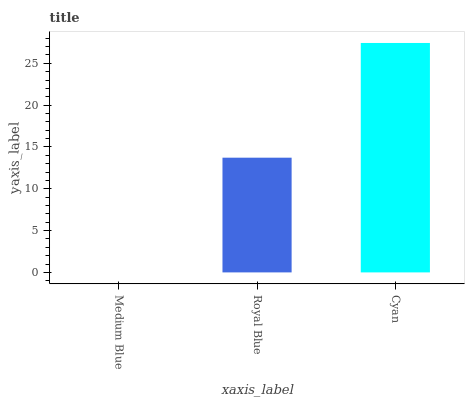Is Medium Blue the minimum?
Answer yes or no. Yes. Is Cyan the maximum?
Answer yes or no. Yes. Is Royal Blue the minimum?
Answer yes or no. No. Is Royal Blue the maximum?
Answer yes or no. No. Is Royal Blue greater than Medium Blue?
Answer yes or no. Yes. Is Medium Blue less than Royal Blue?
Answer yes or no. Yes. Is Medium Blue greater than Royal Blue?
Answer yes or no. No. Is Royal Blue less than Medium Blue?
Answer yes or no. No. Is Royal Blue the high median?
Answer yes or no. Yes. Is Royal Blue the low median?
Answer yes or no. Yes. Is Cyan the high median?
Answer yes or no. No. Is Cyan the low median?
Answer yes or no. No. 